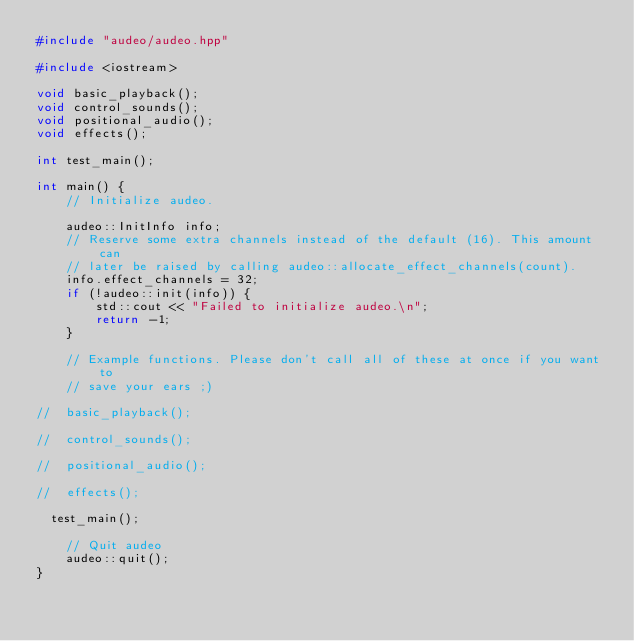<code> <loc_0><loc_0><loc_500><loc_500><_C++_>#include "audeo/audeo.hpp"

#include <iostream>

void basic_playback();
void control_sounds();
void positional_audio();
void effects();

int test_main();

int main() {
    // Initialize audeo.

    audeo::InitInfo info;
    // Reserve some extra channels instead of the default (16). This amount can
    // later be raised by calling audeo::allocate_effect_channels(count).
    info.effect_channels = 32;
    if (!audeo::init(info)) {
        std::cout << "Failed to initialize audeo.\n";
        return -1;
    }

    // Example functions. Please don't call all of these at once if you want to
    // save your ears ;)
    
//	basic_playback();

//	control_sounds();

//	positional_audio();

//	effects();

	test_main();

    // Quit audeo
    audeo::quit();
}
</code> 